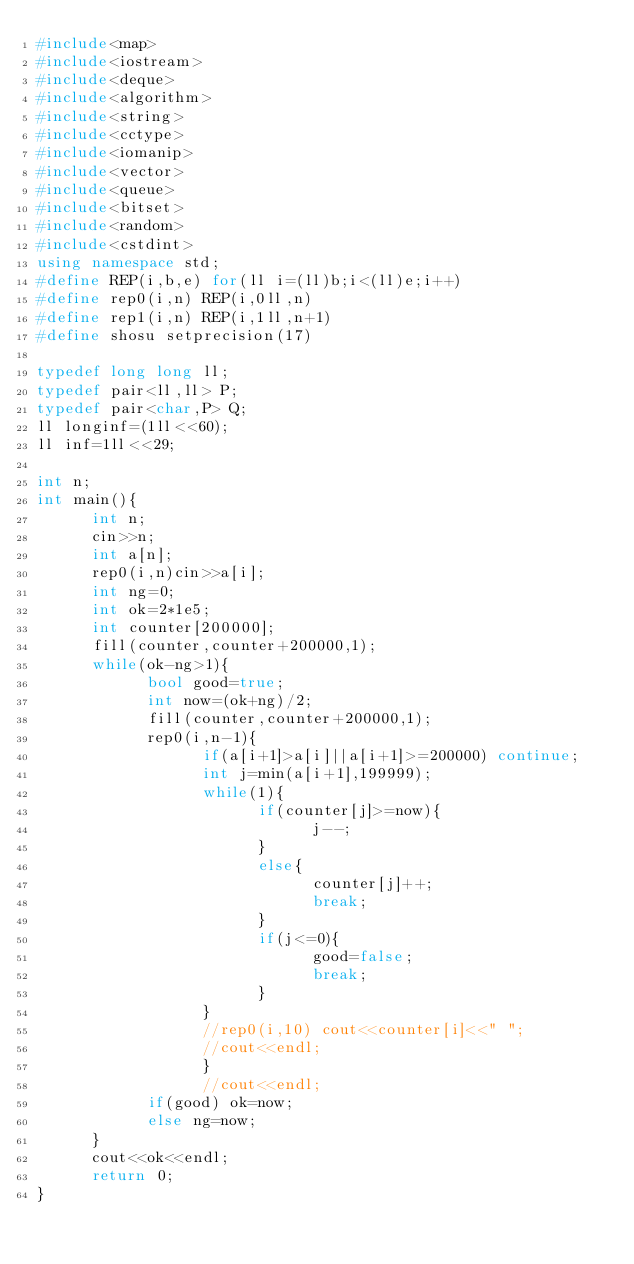<code> <loc_0><loc_0><loc_500><loc_500><_C++_>#include<map>
#include<iostream>
#include<deque>
#include<algorithm>
#include<string>
#include<cctype>
#include<iomanip>
#include<vector>
#include<queue>
#include<bitset>
#include<random>
#include<cstdint>
using namespace std;
#define REP(i,b,e) for(ll i=(ll)b;i<(ll)e;i++)
#define rep0(i,n) REP(i,0ll,n)
#define rep1(i,n) REP(i,1ll,n+1)
#define shosu setprecision(17)
  
typedef long long ll;
typedef pair<ll,ll> P;
typedef pair<char,P> Q;
ll longinf=(1ll<<60);
ll inf=1ll<<29;

int n;
int main(){
      int n;
      cin>>n;
      int a[n];
      rep0(i,n)cin>>a[i];
      int ng=0;
      int ok=2*1e5;
      int counter[200000];
      fill(counter,counter+200000,1);
      while(ok-ng>1){
            bool good=true;
            int now=(ok+ng)/2;
            fill(counter,counter+200000,1);
            rep0(i,n-1){
                  if(a[i+1]>a[i]||a[i+1]>=200000) continue;
                  int j=min(a[i+1],199999);
                  while(1){
                        if(counter[j]>=now){
                              j--;
                        }
                        else{
                              counter[j]++;
                              break;
                        }
                        if(j<=0){
                              good=false;
                              break;
                        }
                  }
                  //rep0(i,10) cout<<counter[i]<<" ";
                  //cout<<endl;
                  }
                  //cout<<endl;
            if(good) ok=now;
            else ng=now;
      }
      cout<<ok<<endl;
      return 0;
}
</code> 